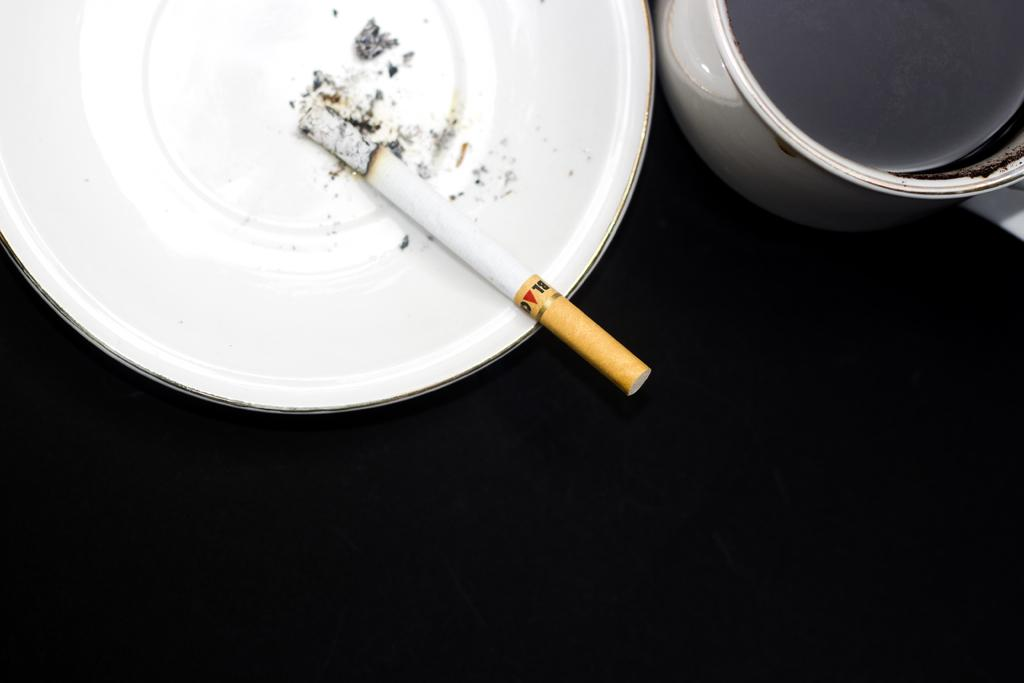What is the main object in the image? There is a cigarette in the image. What is the cigarette placed on? The cigarette is on a white color ceramic plate. What other object is present in the image? There is a coffee cup in the image. What is the surface color of the area where the coffee cup is placed? The coffee cup is on a black surface. Can you see any mountains or lizards in the image? No, there are no mountains or lizards present in the image. 